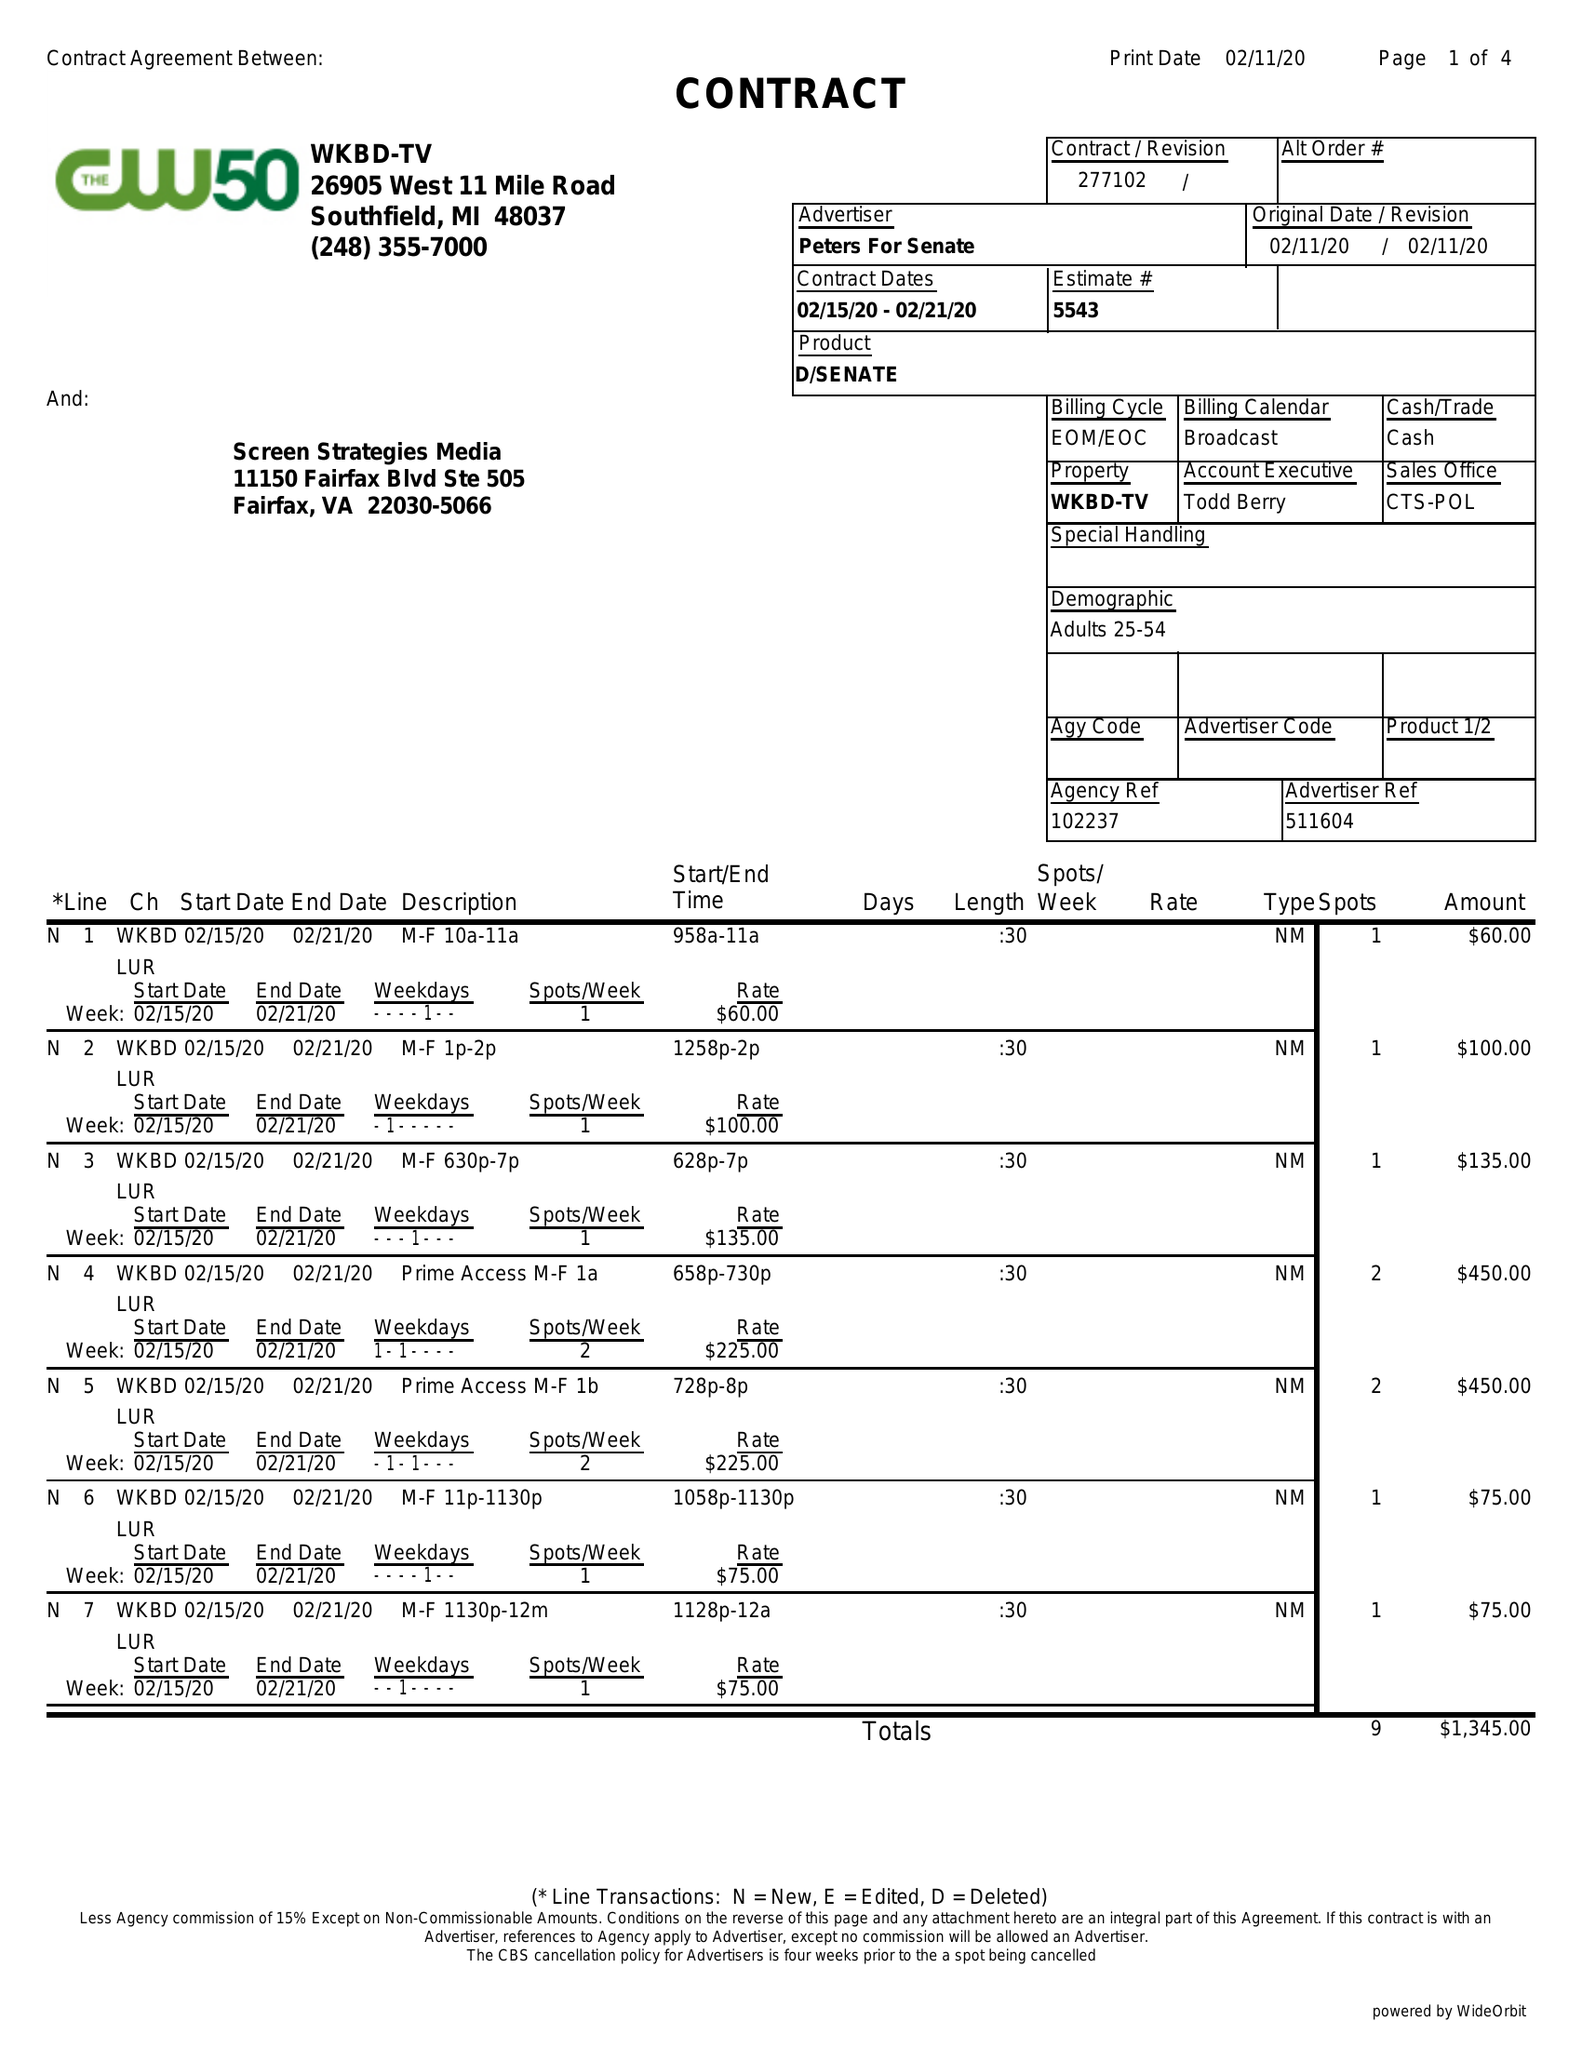What is the value for the advertiser?
Answer the question using a single word or phrase. PETERS FOR SENATE 